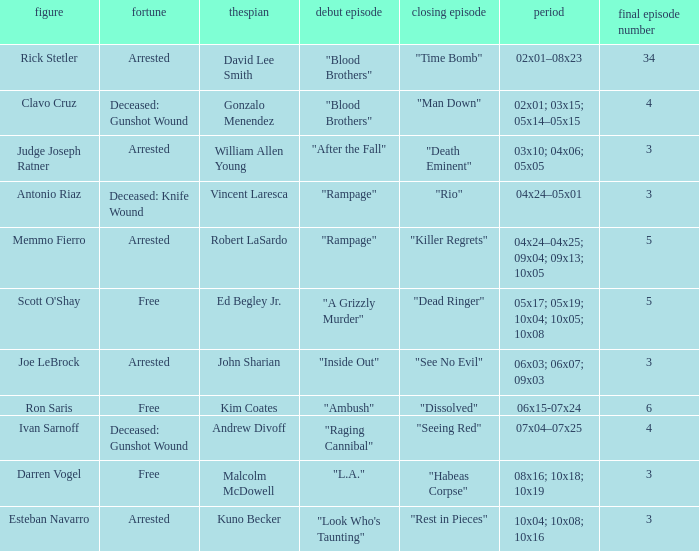What's the actor with character being judge joseph ratner William Allen Young. 